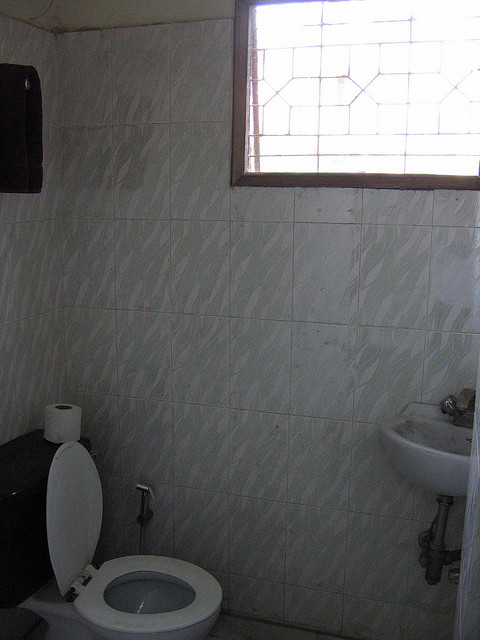<image>Why is the toilet seat open? It is unknown why the toilet seat is open. It could be for cleaning, for use, or someone may have left it open. Why is the toilet seat open? I don't know why the toilet seat is open. It can be due to cleaning, someone left it open, or just for use. 